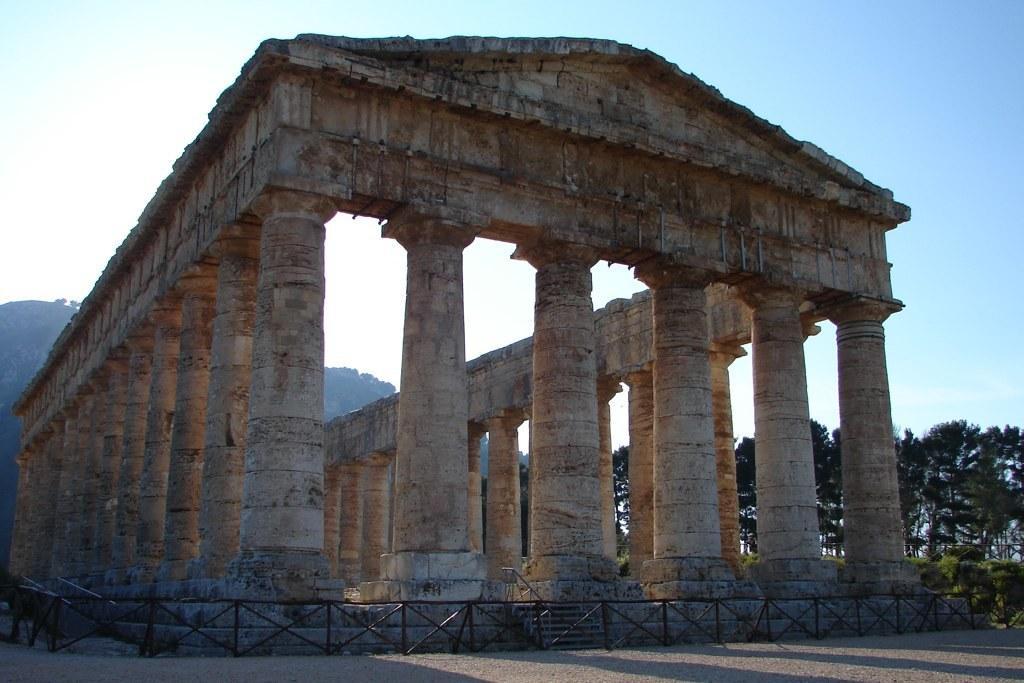How would you summarize this image in a sentence or two? In the picture I can see the ancient construction and there is a metal grill fence around the construction. There are trees on the right side. There are clouds in the sky. 